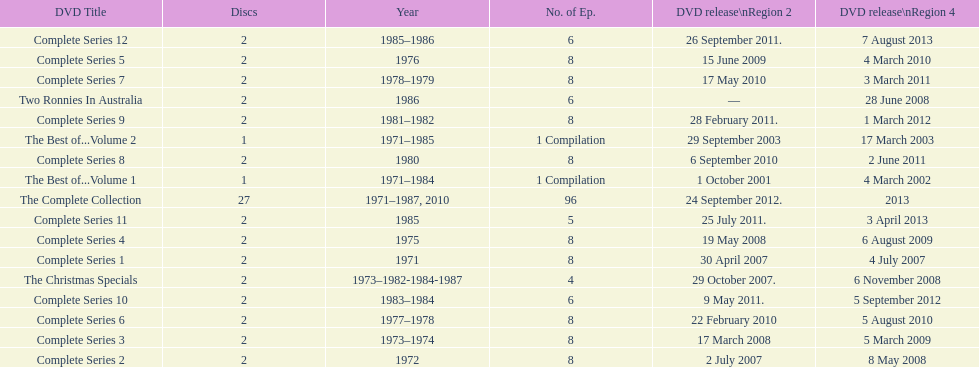How many series had 8 episodes? 9. 